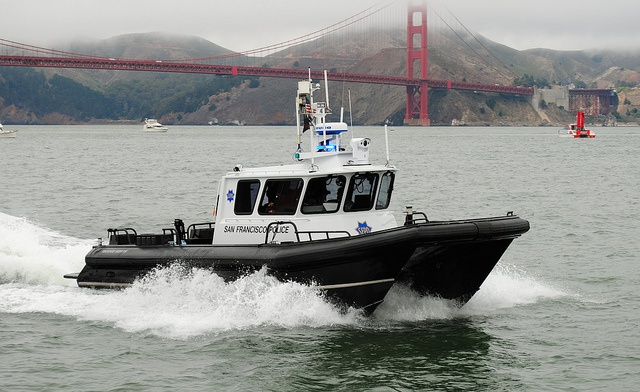Describe the objects in this image and their specific colors. I can see boat in lightgray, black, gray, and darkgray tones, boat in lightgray, brown, darkgray, and gray tones, people in lightgray, black, and gray tones, boat in lightgray, darkgray, and gray tones, and boat in lightgray, gray, and darkgray tones in this image. 